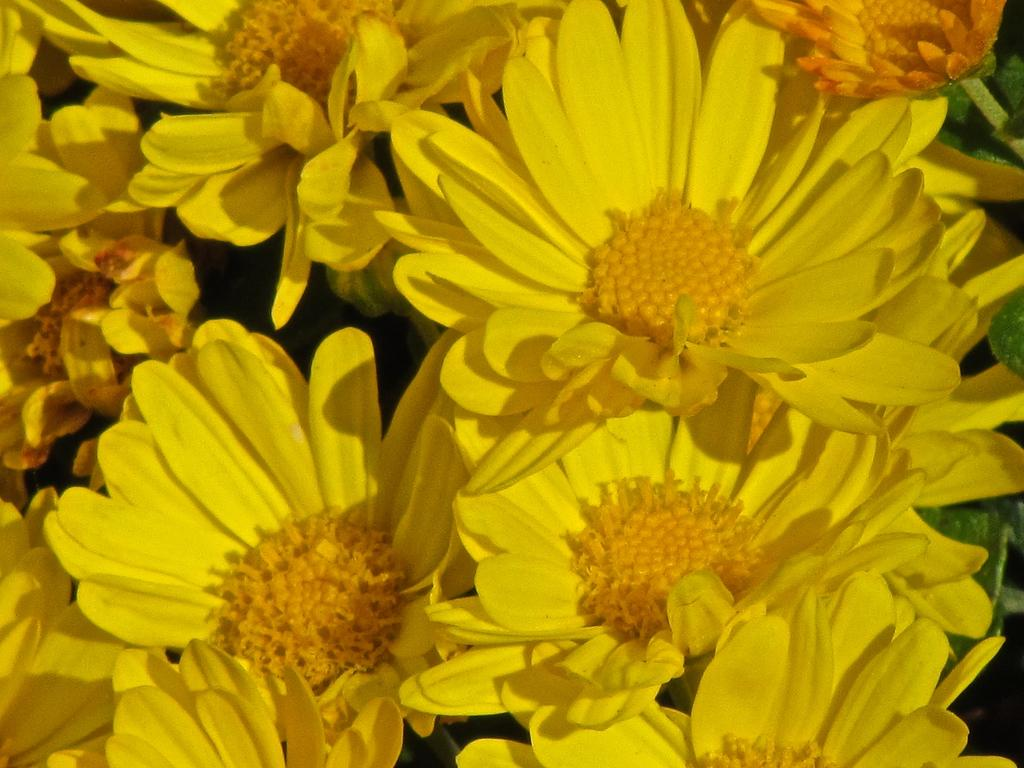What is the main subject of the image? The main subject of the image is a bunch of flowers. What color are the flowers in the image? The flowers are yellow in color. What are the flowers made up of? The flowers have petals. How many times did the flowers shake hands during the event in the image? There is no event or handshakes involving flowers in the image; it simply shows a bunch of yellow flowers with petals. 